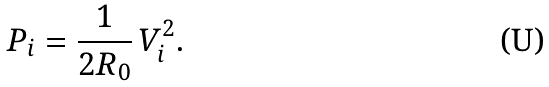<formula> <loc_0><loc_0><loc_500><loc_500>P _ { i } = \frac { 1 } { 2 R _ { 0 } } \, V _ { i } ^ { 2 } .</formula> 